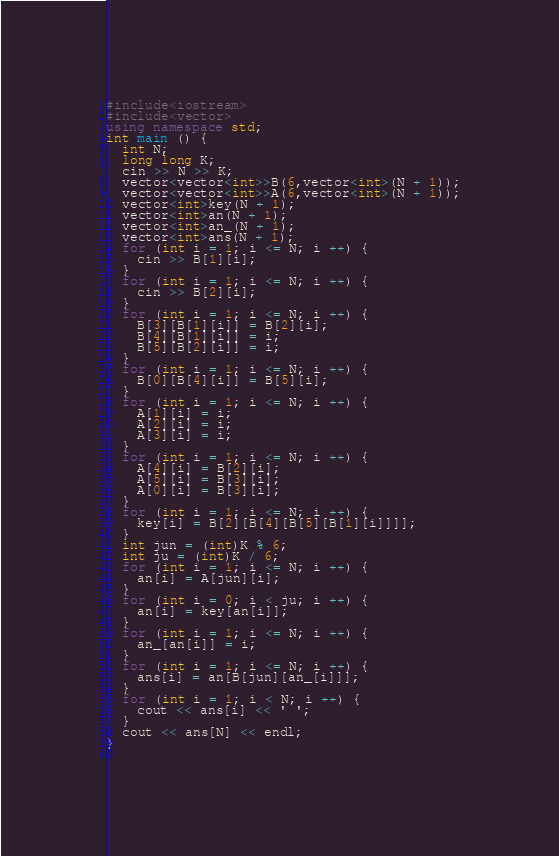Convert code to text. <code><loc_0><loc_0><loc_500><loc_500><_C++_>#include<iostream>
#include<vector>
using namespace std;
int main () {
  int N;
  long long K;
  cin >> N >> K;
  vector<vector<int>>B(6,vector<int>(N + 1));
  vector<vector<int>>A(6,vector<int>(N + 1));
  vector<int>key(N + 1);
  vector<int>an(N + 1);
  vector<int>an_(N + 1);
  vector<int>ans(N + 1);
  for (int i = 1; i <= N; i ++) {
    cin >> B[1][i];
  }
  for (int i = 1; i <= N; i ++) {
    cin >> B[2][i];
  }
  for (int i = 1; i <= N; i ++) {
    B[3][B[1][i]] = B[2][i];
    B[4][B[1][i]] = i;
    B[5][B[2][i]] = i;
  }
  for (int i = 1; i <= N; i ++) {
    B[0][B[4][i]] = B[5][i];
  }
  for (int i = 1; i <= N; i ++) {
    A[1][i] = i;
    A[2][i] = i;
    A[3][i] = i;
  }
  for (int i = 1; i <= N; i ++) {
    A[4][i] = B[2][i];
    A[5][i] = B[3][i];
    A[0][i] = B[3][i];
  }
  for (int i = 1; i <= N; i ++) {
    key[i] = B[2][B[4][B[5][B[1][i]]]];
  }
  int jun = (int)K % 6;
  int ju = (int)K / 6;
  for (int i = 1; i <= N; i ++) {
    an[i] = A[jun][i];
  }
  for (int i = 0; i < ju; i ++) {
    an[i] = key[an[i]];
  }
  for (int i = 1; i <= N; i ++) {
    an_[an[i]] = i;
  }
  for (int i = 1; i <= N; i ++) {
    ans[i] = an[B[jun][an_[i]]];
  }
  for (int i = 1; i < N; i ++) {
    cout << ans[i] << ' ';
  }
  cout << ans[N] << endl;
}
  

</code> 